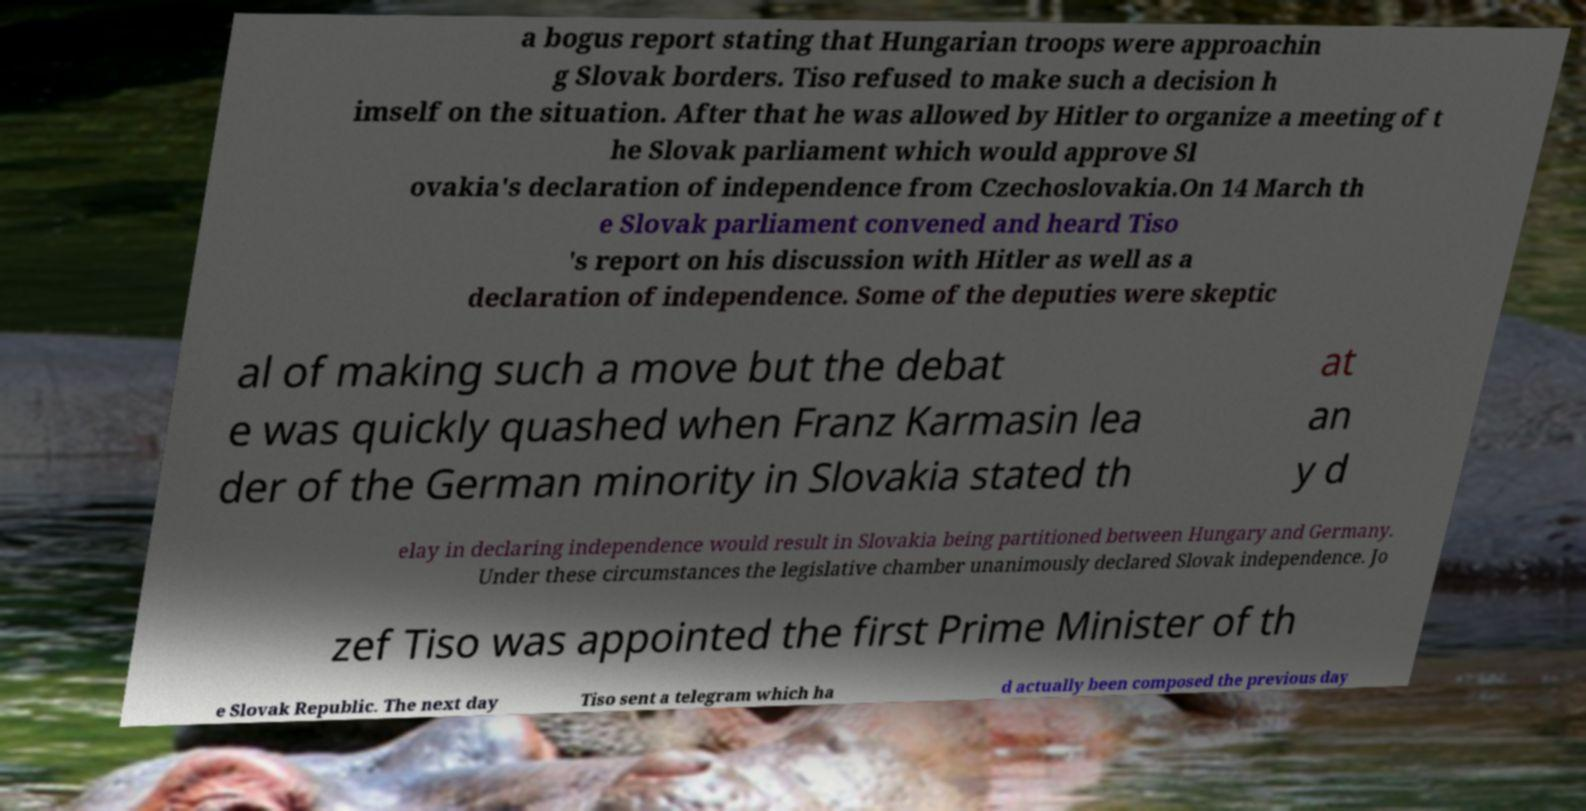Can you read and provide the text displayed in the image?This photo seems to have some interesting text. Can you extract and type it out for me? a bogus report stating that Hungarian troops were approachin g Slovak borders. Tiso refused to make such a decision h imself on the situation. After that he was allowed by Hitler to organize a meeting of t he Slovak parliament which would approve Sl ovakia's declaration of independence from Czechoslovakia.On 14 March th e Slovak parliament convened and heard Tiso 's report on his discussion with Hitler as well as a declaration of independence. Some of the deputies were skeptic al of making such a move but the debat e was quickly quashed when Franz Karmasin lea der of the German minority in Slovakia stated th at an y d elay in declaring independence would result in Slovakia being partitioned between Hungary and Germany. Under these circumstances the legislative chamber unanimously declared Slovak independence. Jo zef Tiso was appointed the first Prime Minister of th e Slovak Republic. The next day Tiso sent a telegram which ha d actually been composed the previous day 